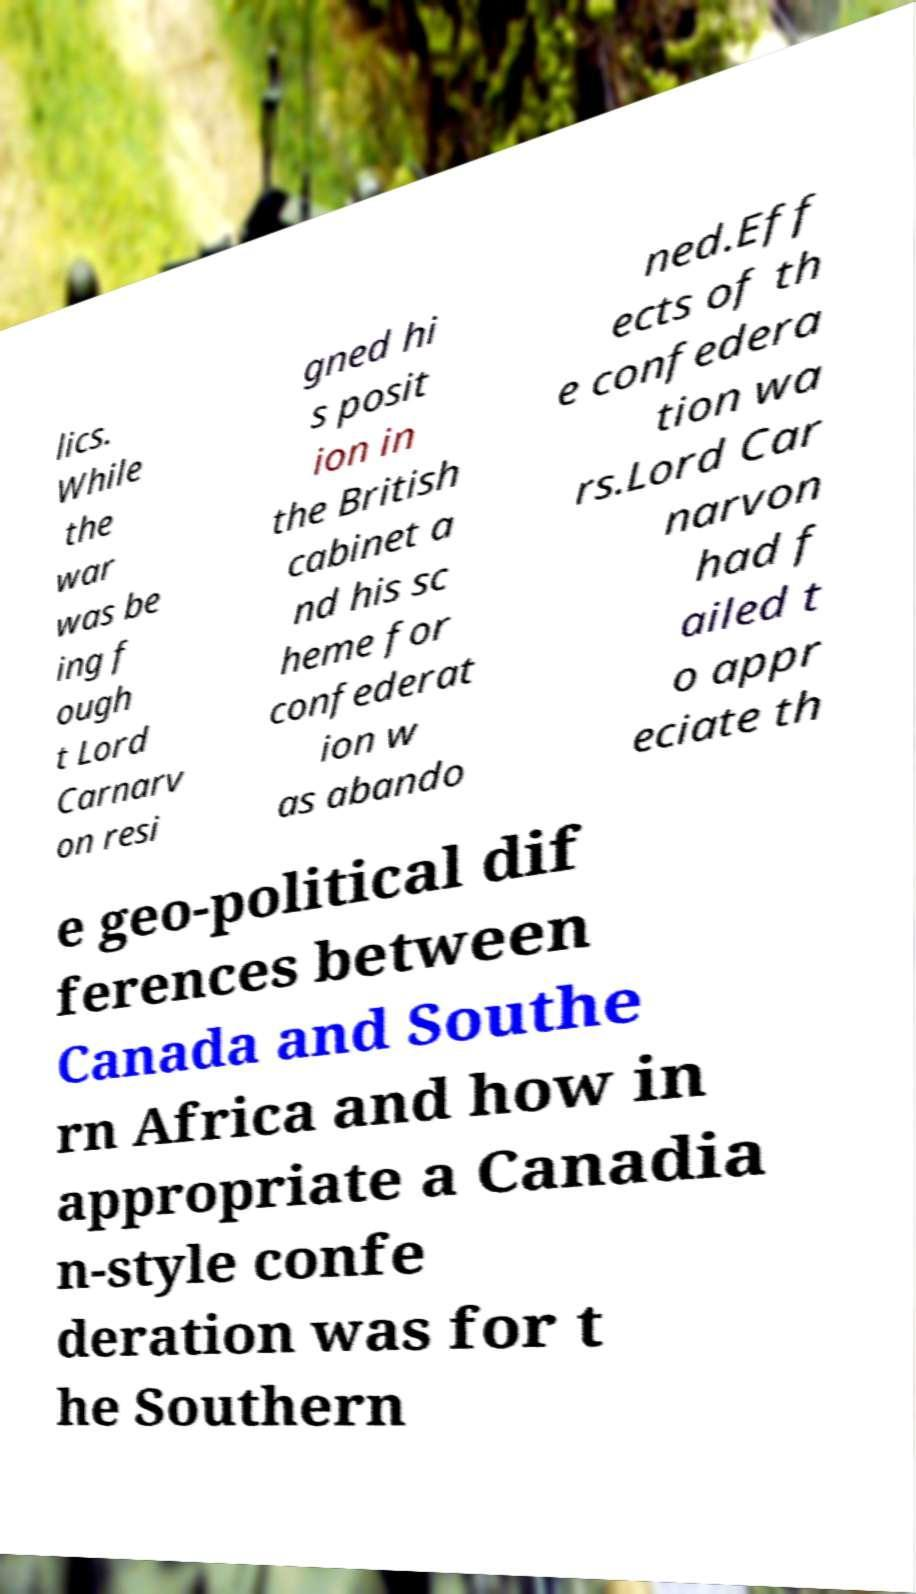There's text embedded in this image that I need extracted. Can you transcribe it verbatim? lics. While the war was be ing f ough t Lord Carnarv on resi gned hi s posit ion in the British cabinet a nd his sc heme for confederat ion w as abando ned.Eff ects of th e confedera tion wa rs.Lord Car narvon had f ailed t o appr eciate th e geo-political dif ferences between Canada and Southe rn Africa and how in appropriate a Canadia n-style confe deration was for t he Southern 